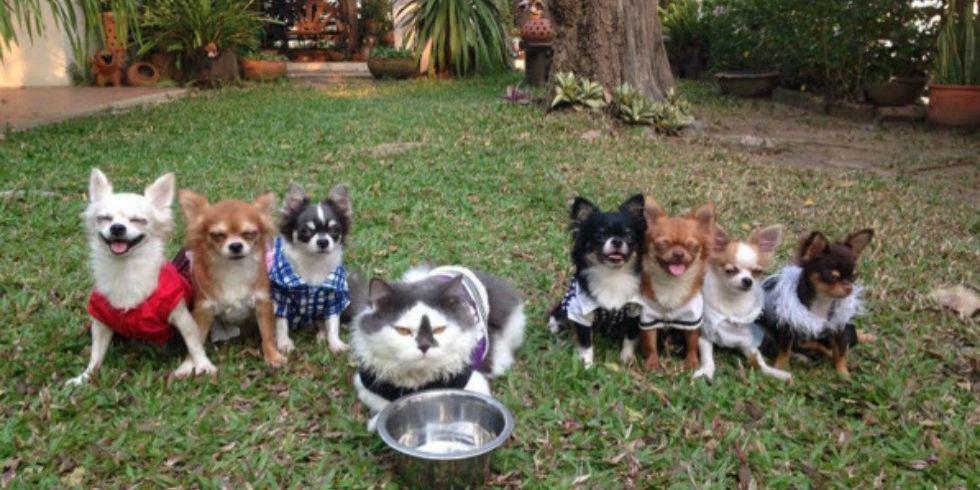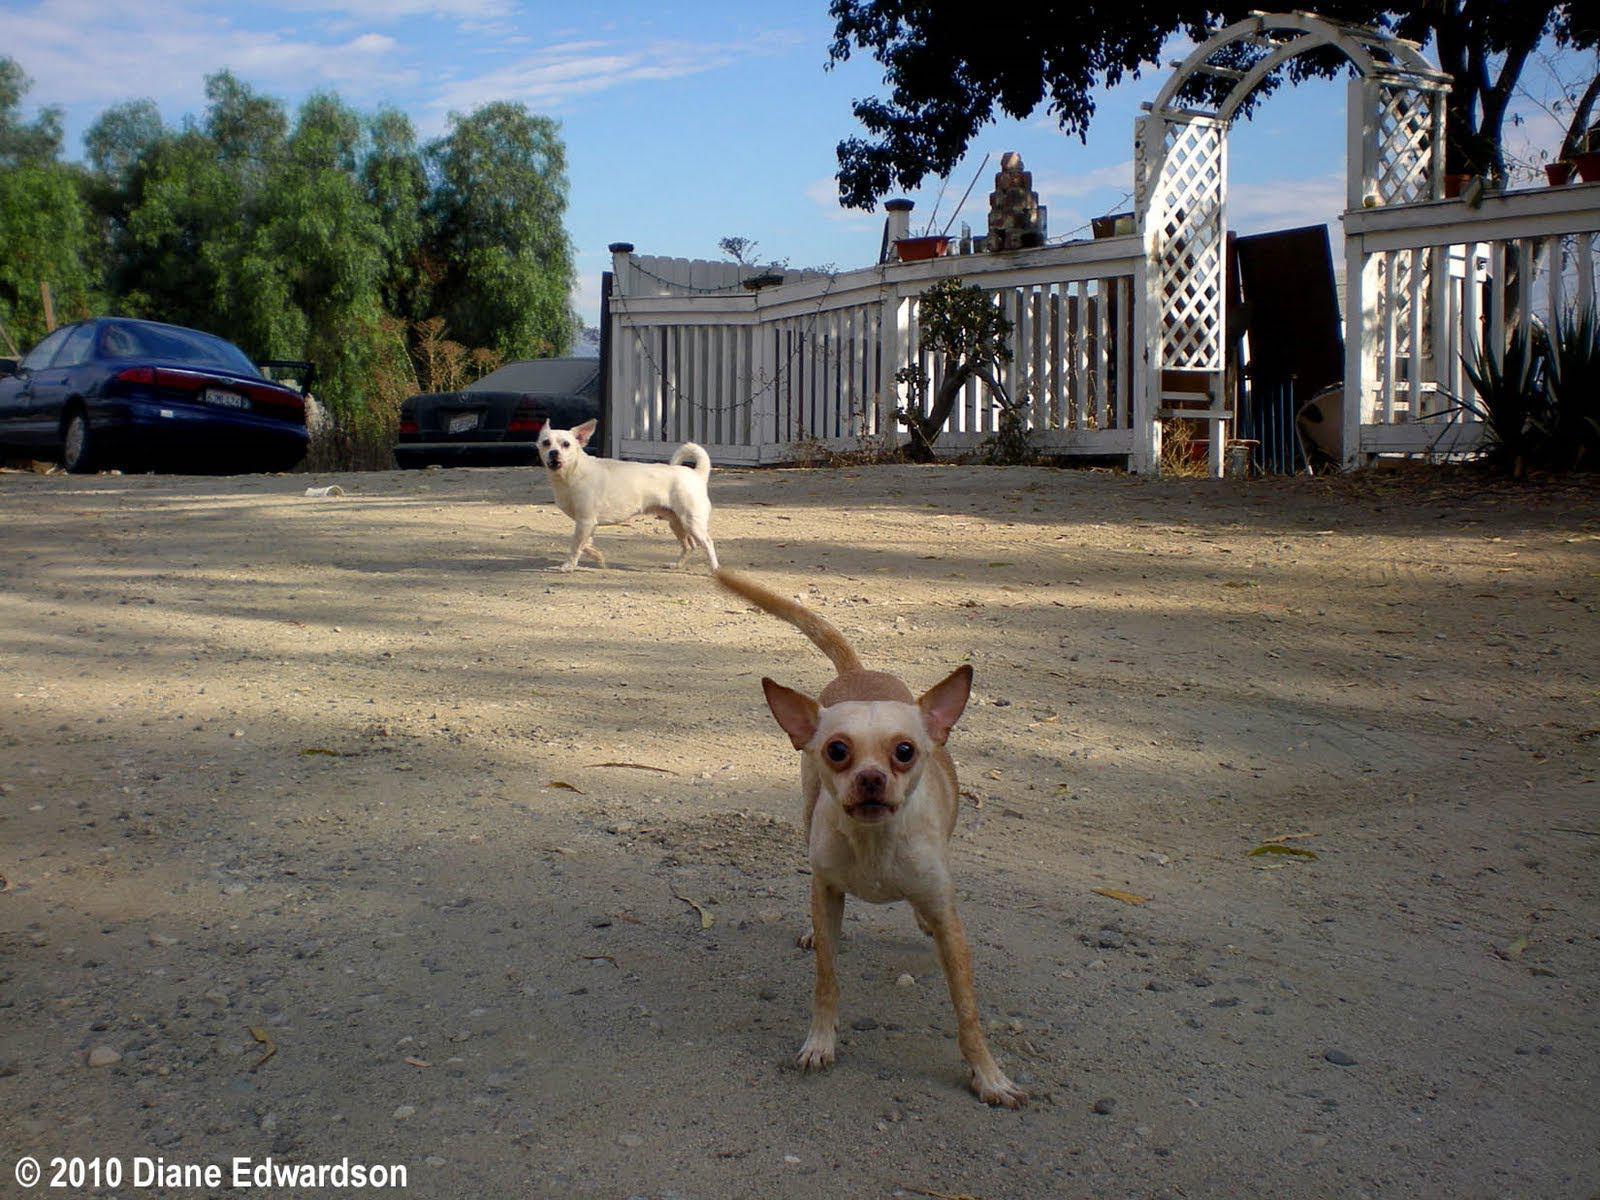The first image is the image on the left, the second image is the image on the right. Assess this claim about the two images: "In one image, seven small dogs and a large gray and white cat are in a shady grassy yard area with trees and shrubs.". Correct or not? Answer yes or no. Yes. 